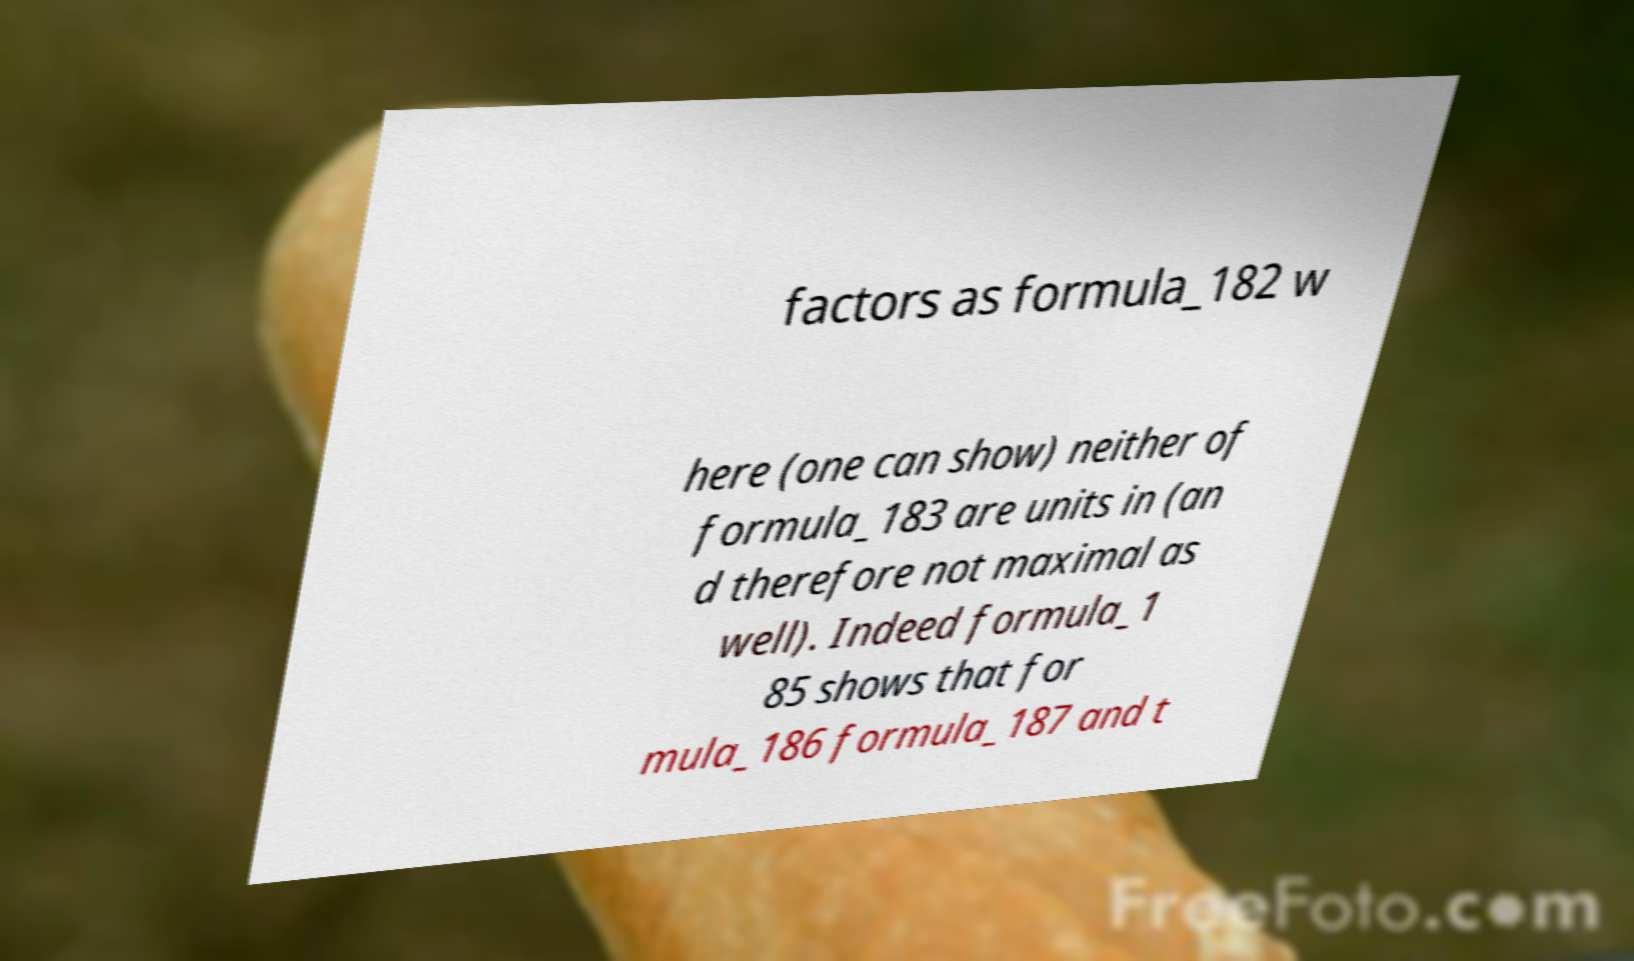For documentation purposes, I need the text within this image transcribed. Could you provide that? factors as formula_182 w here (one can show) neither of formula_183 are units in (an d therefore not maximal as well). Indeed formula_1 85 shows that for mula_186 formula_187 and t 